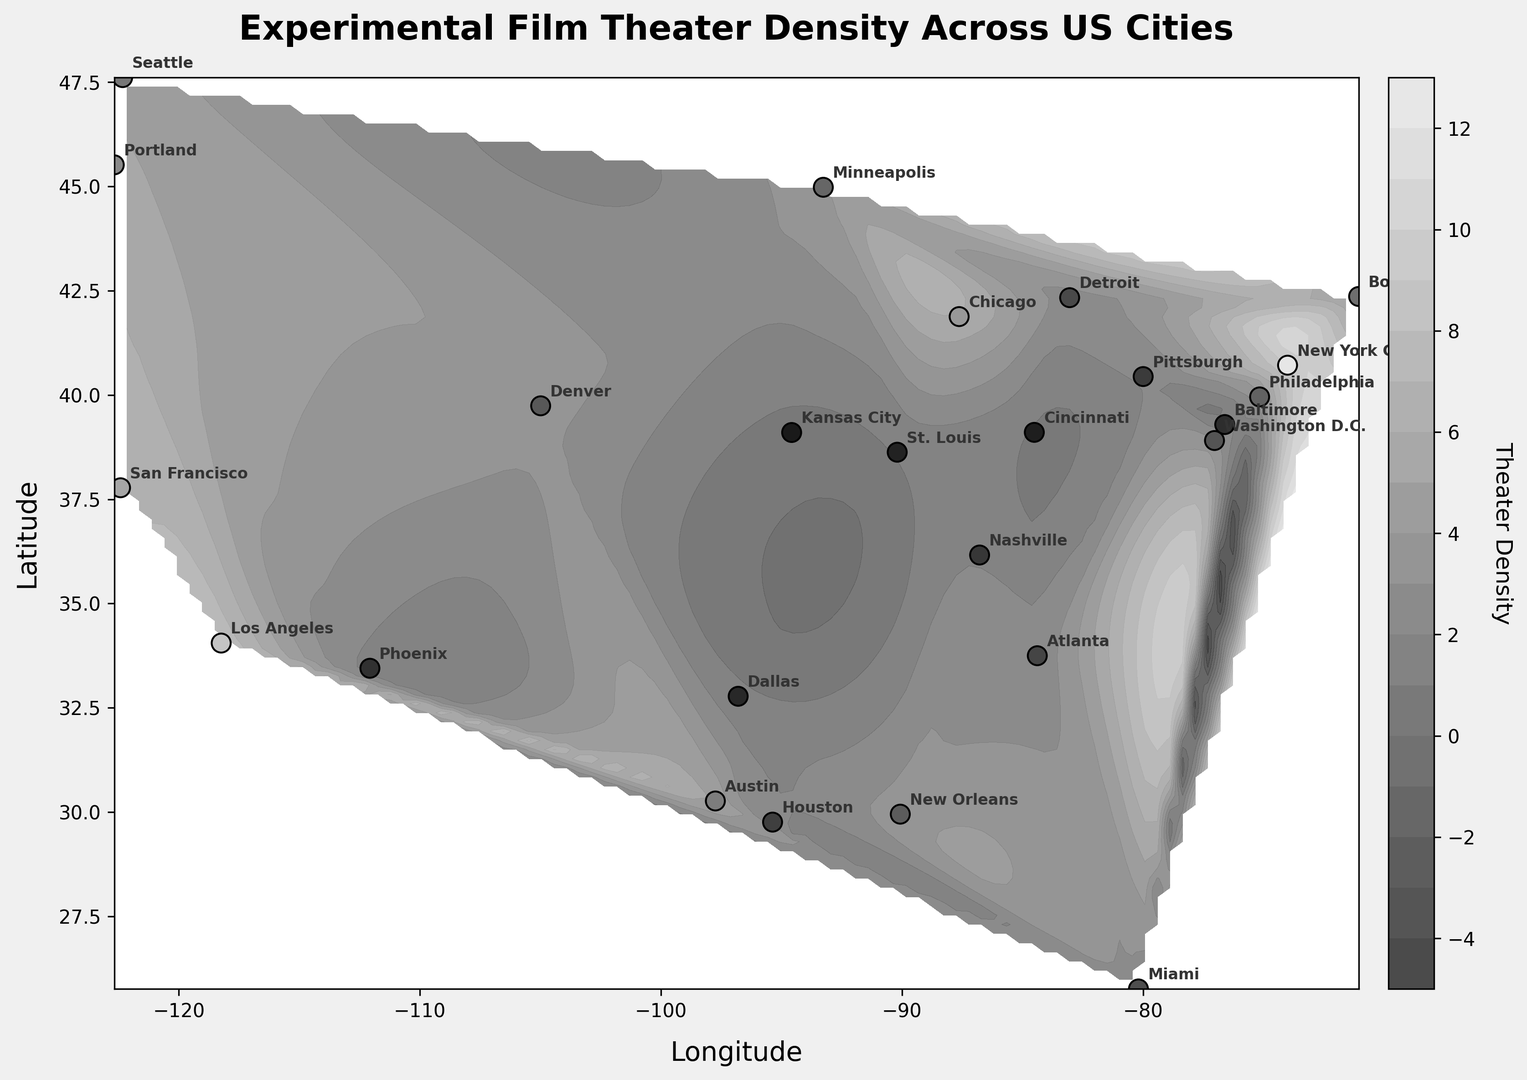What city has the highest density of experimental film theaters? The contour plot shows the highest density as the darkest color and the scatter points are annotated with cities. New York City appears to be at the center of the darkest region with a density of 9.2.
Answer: New York City Which cities are marked at the higher density region but not the highest? By examining the regions slightly lighter than the darkest and near New York City's mark, Los Angeles (7.8) and San Francisco (6.5) are notable.
Answer: Los Angeles and San Francisco Is there a significant difference in density between New York City and Chicago? In the plot, New York City’s density is 9.2 and Chicago’s density is 5.9. The difference is calculated as 9.2 - 5.9 = 3.3, which is notable.
Answer: Yes, the difference is 3.3 How does the density of experimental film theaters in Portland compare to that in Miami? Portland has a density of 5.3, and Miami has a density of 2.9. Clearly, Portland’s density is higher.
Answer: Portland is higher What’s the average density of the top three cities by density? The top three cities are New York City (9.2), Los Angeles (7.8), and San Francisco (6.5). Average density = (9.2 + 7.8 + 6.5) / 3 = 7.833.
Answer: 7.833 Is there a clear clustering of high-density regions in specific geographic areas? The contour plot emphasizes darker and lighter regions. It is noticeable that the highest density marks cluster around the East and West coasts, particularly around New York City and Los Angeles.
Answer: Yes, around the East and West coasts Do Washington D.C. and Boston have similar densities? Washington D.C. has a density of 3.1, whereas Boston has a density of 4.2. Boston’s value is higher.
Answer: No, Boston is higher Compare the color shading around Austin and Seattle based on density. Austin, with a density of 4.8, and Seattle, with a density of 4.6, have similar color shading. Both fall in a relatively high but not the highest density range.
Answer: Similar shading Which city has the lowest recorded density? Checking the annotated scatter points, Kansas City has a density of 0.7, the lightest among the marked regions.
Answer: Kansas City 